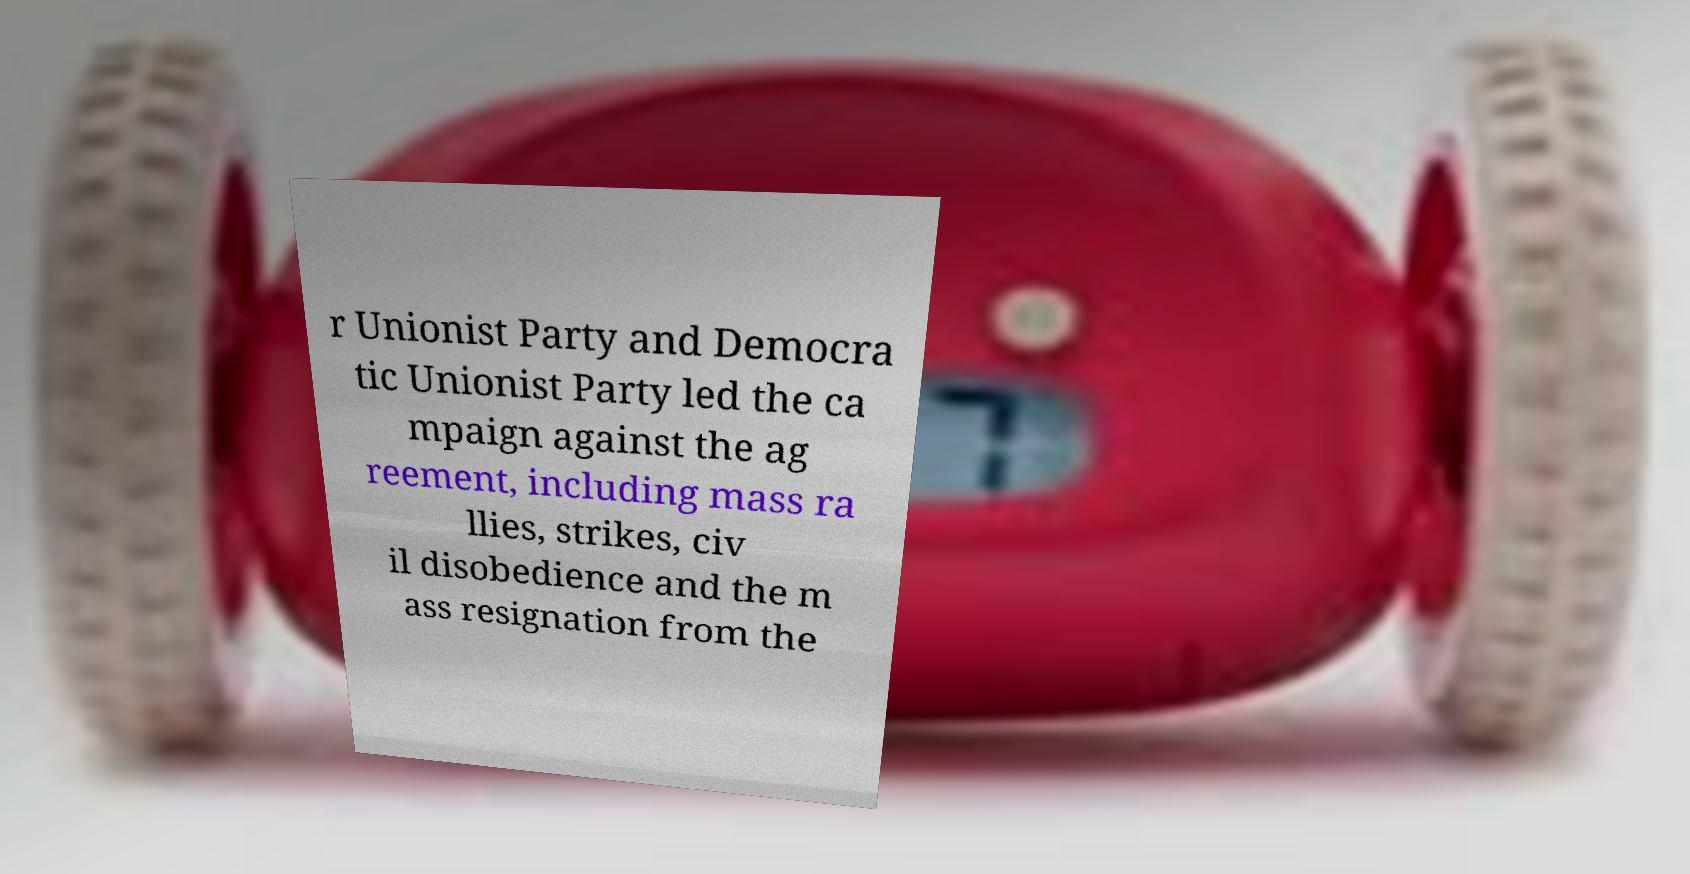Can you accurately transcribe the text from the provided image for me? r Unionist Party and Democra tic Unionist Party led the ca mpaign against the ag reement, including mass ra llies, strikes, civ il disobedience and the m ass resignation from the 